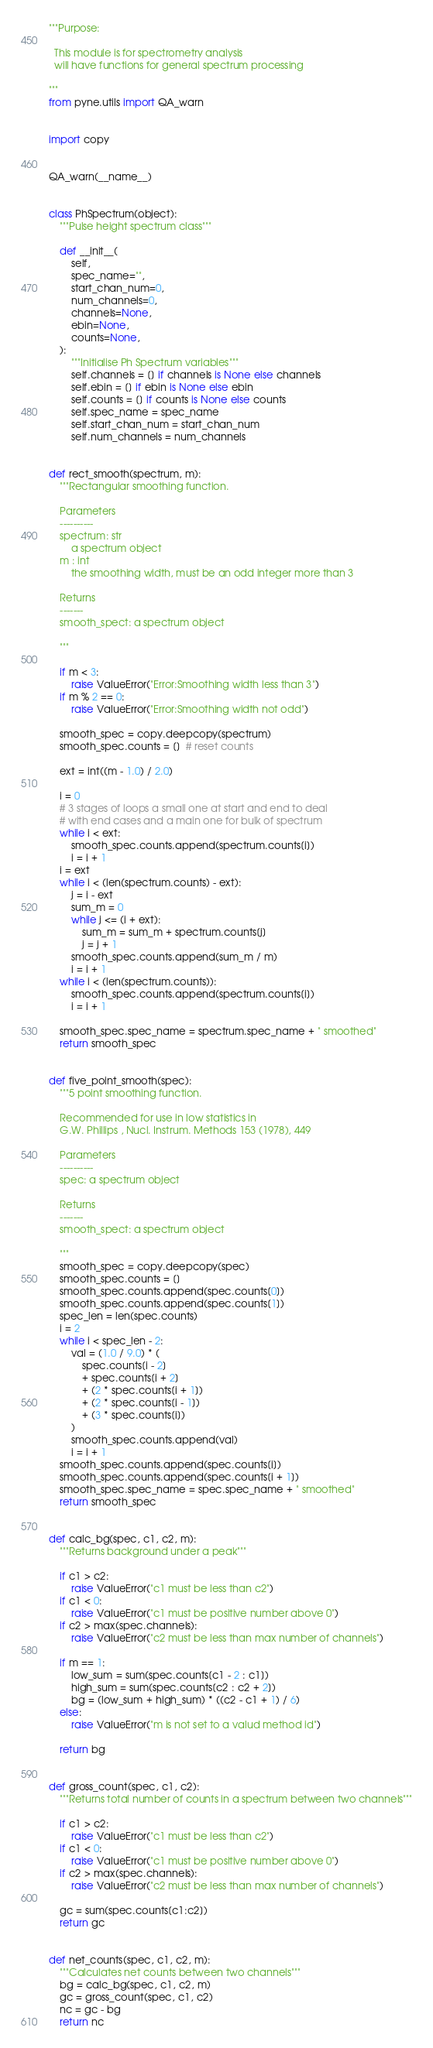<code> <loc_0><loc_0><loc_500><loc_500><_Python_>"""Purpose:

  This module is for spectrometry analysis
  will have functions for general spectrum processing

"""
from pyne.utils import QA_warn


import copy


QA_warn(__name__)


class PhSpectrum(object):
    """Pulse height spectrum class"""

    def __init__(
        self,
        spec_name="",
        start_chan_num=0,
        num_channels=0,
        channels=None,
        ebin=None,
        counts=None,
    ):
        """Initialise Ph Spectrum variables"""
        self.channels = [] if channels is None else channels
        self.ebin = [] if ebin is None else ebin
        self.counts = [] if counts is None else counts
        self.spec_name = spec_name
        self.start_chan_num = start_chan_num
        self.num_channels = num_channels


def rect_smooth(spectrum, m):
    """Rectangular smoothing function.

    Parameters
    ----------
    spectrum: str
        a spectrum object
    m : int
        the smoothing width, must be an odd integer more than 3

    Returns
    -------
    smooth_spect: a spectrum object

    """

    if m < 3:
        raise ValueError("Error:Smoothing width less than 3")
    if m % 2 == 0:
        raise ValueError("Error:Smoothing width not odd")

    smooth_spec = copy.deepcopy(spectrum)
    smooth_spec.counts = []  # reset counts

    ext = int((m - 1.0) / 2.0)

    i = 0
    # 3 stages of loops a small one at start and end to deal
    # with end cases and a main one for bulk of spectrum
    while i < ext:
        smooth_spec.counts.append(spectrum.counts[i])
        i = i + 1
    i = ext
    while i < (len(spectrum.counts) - ext):
        j = i - ext
        sum_m = 0
        while j <= (i + ext):
            sum_m = sum_m + spectrum.counts[j]
            j = j + 1
        smooth_spec.counts.append(sum_m / m)
        i = i + 1
    while i < (len(spectrum.counts)):
        smooth_spec.counts.append(spectrum.counts[i])
        i = i + 1

    smooth_spec.spec_name = spectrum.spec_name + " smoothed"
    return smooth_spec


def five_point_smooth(spec):
    """5 point smoothing function.

    Recommended for use in low statistics in
    G.W. Phillips , Nucl. Instrum. Methods 153 (1978), 449

    Parameters
    ----------
    spec: a spectrum object

    Returns
    -------
    smooth_spect: a spectrum object

    """
    smooth_spec = copy.deepcopy(spec)
    smooth_spec.counts = []
    smooth_spec.counts.append(spec.counts[0])
    smooth_spec.counts.append(spec.counts[1])
    spec_len = len(spec.counts)
    i = 2
    while i < spec_len - 2:
        val = (1.0 / 9.0) * (
            spec.counts[i - 2]
            + spec.counts[i + 2]
            + (2 * spec.counts[i + 1])
            + (2 * spec.counts[i - 1])
            + (3 * spec.counts[i])
        )
        smooth_spec.counts.append(val)
        i = i + 1
    smooth_spec.counts.append(spec.counts[i])
    smooth_spec.counts.append(spec.counts[i + 1])
    smooth_spec.spec_name = spec.spec_name + " smoothed"
    return smooth_spec


def calc_bg(spec, c1, c2, m):
    """Returns background under a peak"""

    if c1 > c2:
        raise ValueError("c1 must be less than c2")
    if c1 < 0:
        raise ValueError("c1 must be positive number above 0")
    if c2 > max(spec.channels):
        raise ValueError("c2 must be less than max number of channels")

    if m == 1:
        low_sum = sum(spec.counts[c1 - 2 : c1])
        high_sum = sum(spec.counts[c2 : c2 + 2])
        bg = (low_sum + high_sum) * ((c2 - c1 + 1) / 6)
    else:
        raise ValueError("m is not set to a valud method id")

    return bg


def gross_count(spec, c1, c2):
    """Returns total number of counts in a spectrum between two channels"""

    if c1 > c2:
        raise ValueError("c1 must be less than c2")
    if c1 < 0:
        raise ValueError("c1 must be positive number above 0")
    if c2 > max(spec.channels):
        raise ValueError("c2 must be less than max number of channels")

    gc = sum(spec.counts[c1:c2])
    return gc


def net_counts(spec, c1, c2, m):
    """Calculates net counts between two channels"""
    bg = calc_bg(spec, c1, c2, m)
    gc = gross_count(spec, c1, c2)
    nc = gc - bg
    return nc
</code> 